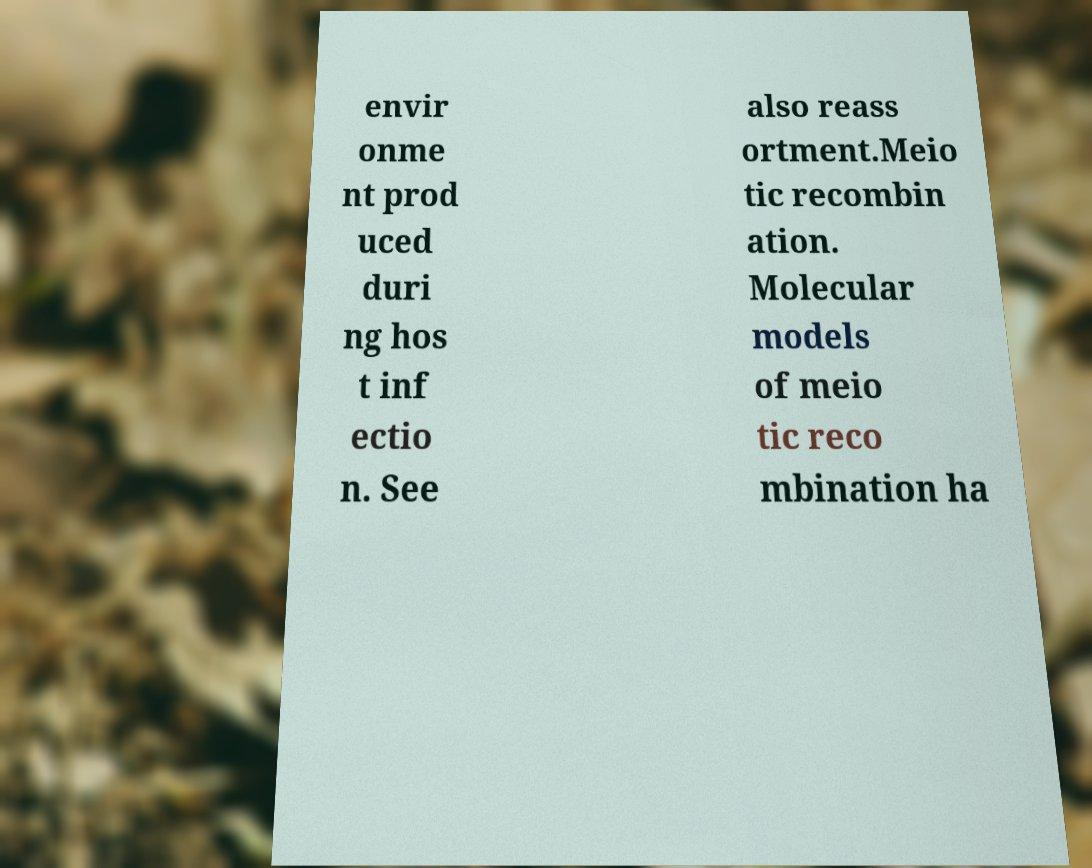Can you read and provide the text displayed in the image?This photo seems to have some interesting text. Can you extract and type it out for me? envir onme nt prod uced duri ng hos t inf ectio n. See also reass ortment.Meio tic recombin ation. Molecular models of meio tic reco mbination ha 